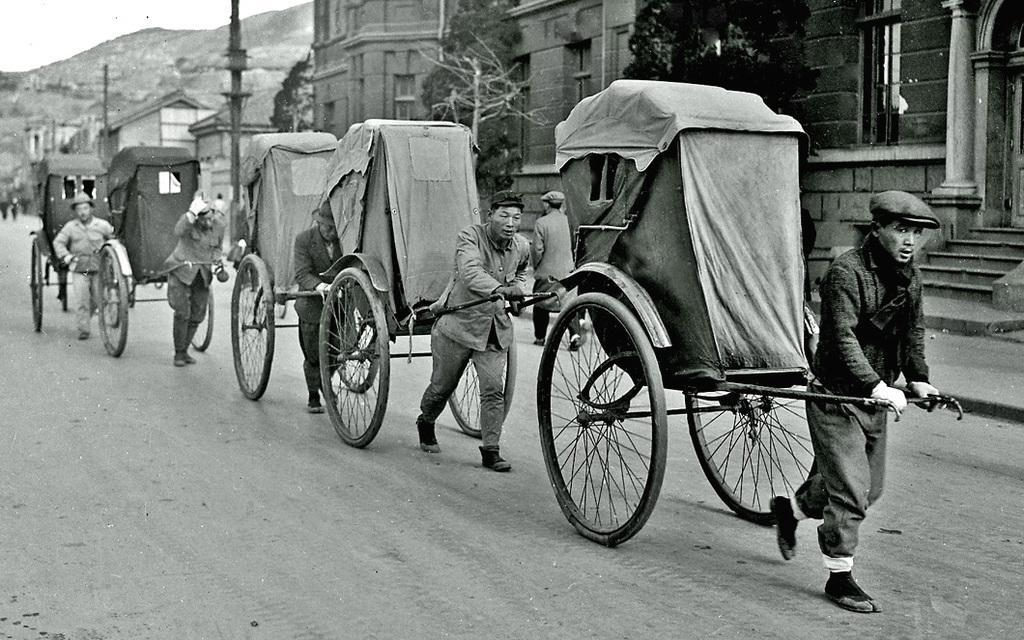Can you describe this image briefly? In this picture I can see a number of people pulling rickshaws. I can see trees. I can see the buildings. I can see the road. 